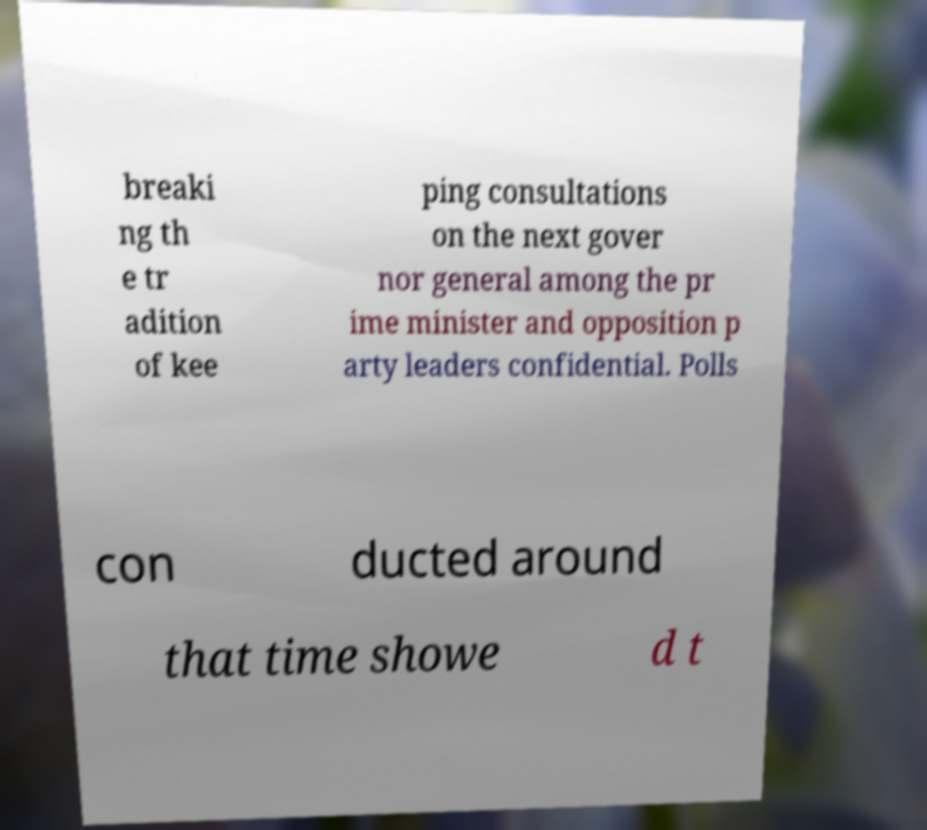Could you assist in decoding the text presented in this image and type it out clearly? breaki ng th e tr adition of kee ping consultations on the next gover nor general among the pr ime minister and opposition p arty leaders confidential. Polls con ducted around that time showe d t 